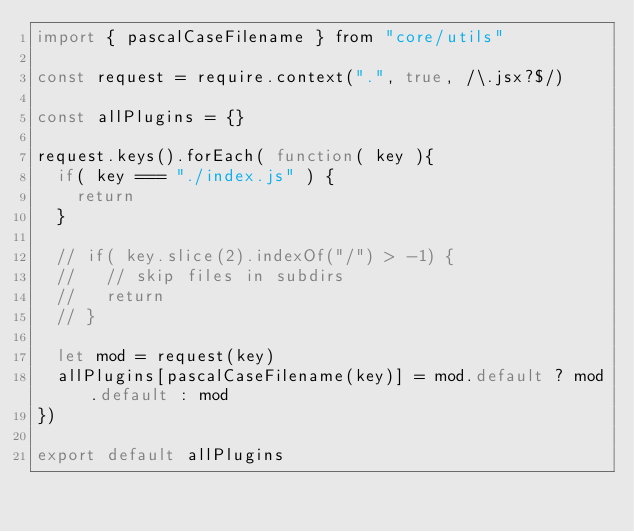Convert code to text. <code><loc_0><loc_0><loc_500><loc_500><_JavaScript_>import { pascalCaseFilename } from "core/utils"

const request = require.context(".", true, /\.jsx?$/)

const allPlugins = {}

request.keys().forEach( function( key ){
  if( key === "./index.js" ) {
    return
  }

  // if( key.slice(2).indexOf("/") > -1) {
  //   // skip files in subdirs
  //   return
  // }

  let mod = request(key)
  allPlugins[pascalCaseFilename(key)] = mod.default ? mod.default : mod
})

export default allPlugins
</code> 